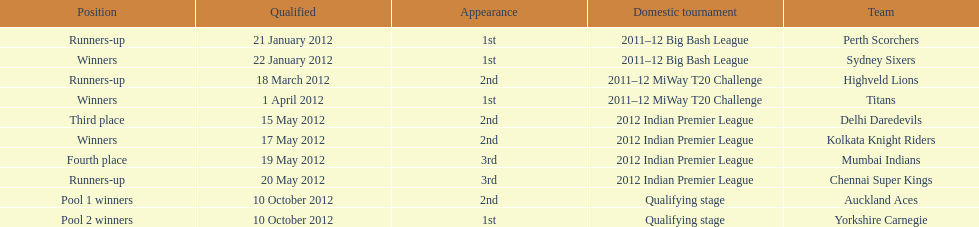Which team came in after the titans in the miway t20 challenge? Highveld Lions. 